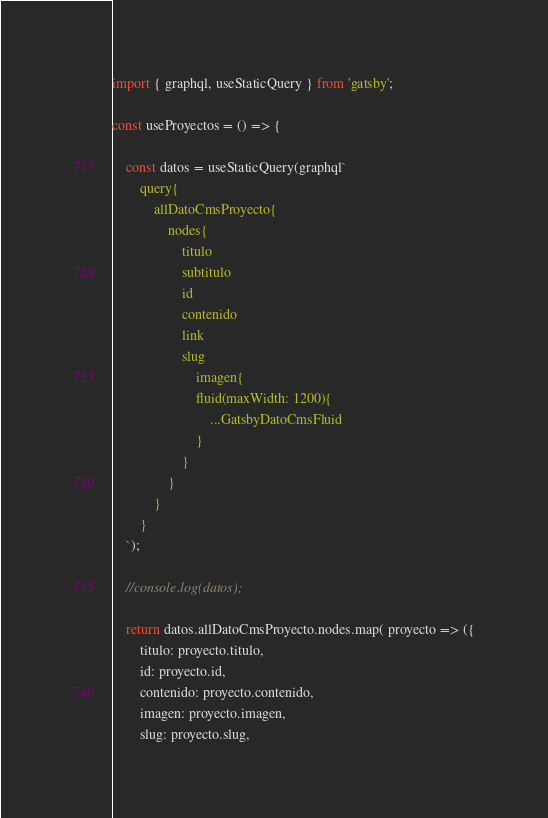Convert code to text. <code><loc_0><loc_0><loc_500><loc_500><_JavaScript_>import { graphql, useStaticQuery } from 'gatsby';

const useProyectos = () => {

    const datos = useStaticQuery(graphql`
        query{
            allDatoCmsProyecto{
                nodes{
                    titulo
                    subtitulo
                    id
                    contenido
                    link
                    slug
                        imagen{
                        fluid(maxWidth: 1200){
                            ...GatsbyDatoCmsFluid
                        }
                    }
                }
            }
        }
    `);

    //console.log(datos);

    return datos.allDatoCmsProyecto.nodes.map( proyecto => ({
        titulo: proyecto.titulo,
        id: proyecto.id,
        contenido: proyecto.contenido,
        imagen: proyecto.imagen,
        slug: proyecto.slug,</code> 